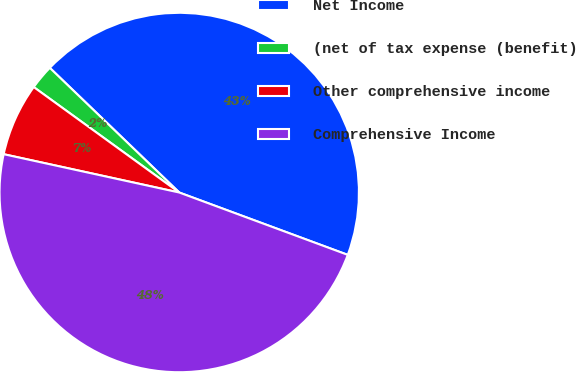Convert chart to OTSL. <chart><loc_0><loc_0><loc_500><loc_500><pie_chart><fcel>Net Income<fcel>(net of tax expense (benefit)<fcel>Other comprehensive income<fcel>Comprehensive Income<nl><fcel>43.44%<fcel>2.22%<fcel>6.56%<fcel>47.78%<nl></chart> 